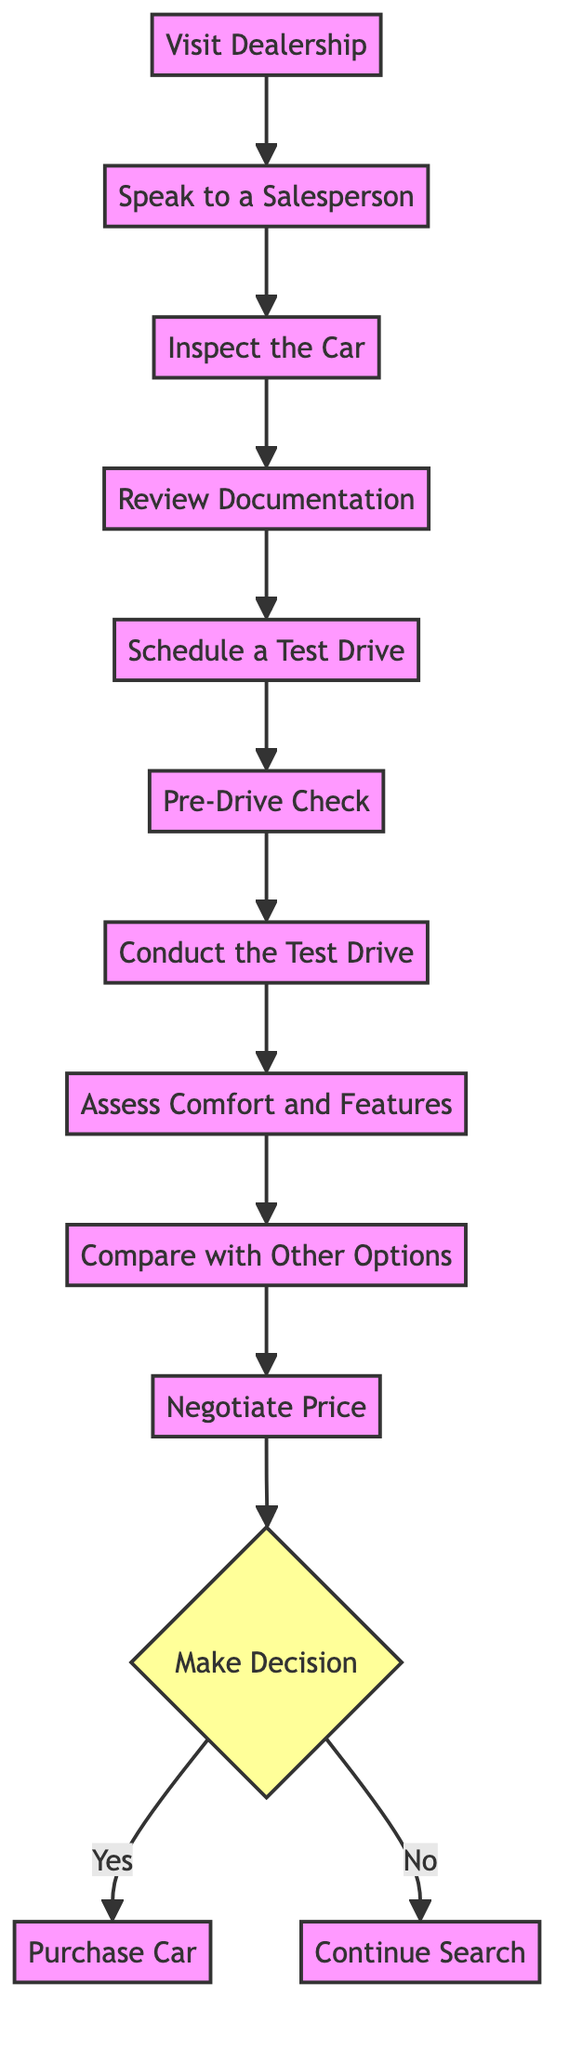What is the first step in the process? The first step in the process is represented by the node "Visit Dealership." This node is connected to the starting point of the flowchart, indicating that it must be completed before any other steps can follow.
Answer: Visit Dealership How many nodes are in the diagram? To find the total number of nodes, we count each unique step represented in the flowchart, including the decision node. There are a total of 12 nodes.
Answer: 12 What follows after "Schedule a Test Drive"? The node that follows "Schedule a Test Drive" is "Pre-Drive Check," which indicates the next step in the process after scheduling the test drive.
Answer: Pre-Drive Check What decision is made at the "Make Decision" node? The "Make Decision" node presents two options: one leads to "Purchase Car" and the other to "Continue Search." This means a decision must be made regarding the purchase based on prior steps.
Answer: Yes / No What is the last step if the decision is "No"? If the decision is "No" at the "Make Decision" node, the process continues to the node "Continue Search," indicating that the user will not proceed with the purchase.
Answer: Continue Search Which step involves discussing preferences? The step that involves discussing preferences is "Speak to a Salesperson." This interaction is essential for receiving guidance on suitable car options based on individual needs and budget.
Answer: Speak to a Salesperson What is the relationship between "Inspect the Car" and "Review Documentation"? The relationship is sequential; after "Inspect the Car," the next step is "Review Documentation," indicating that these two steps must occur in order.
Answer: Sequential How many steps are there before making a decision? To determine the number of steps before making a decision, we tally all the nodes leading to "Make Decision." There are 9 steps before reaching this decision node.
Answer: 9 What do you do before conducting the test drive? Before conducting the test drive, the step labeled "Pre-Drive Check" must be completed. This step ensures the driver is comfortable and familiar with the vehicle controls prior to driving.
Answer: Pre-Drive Check 